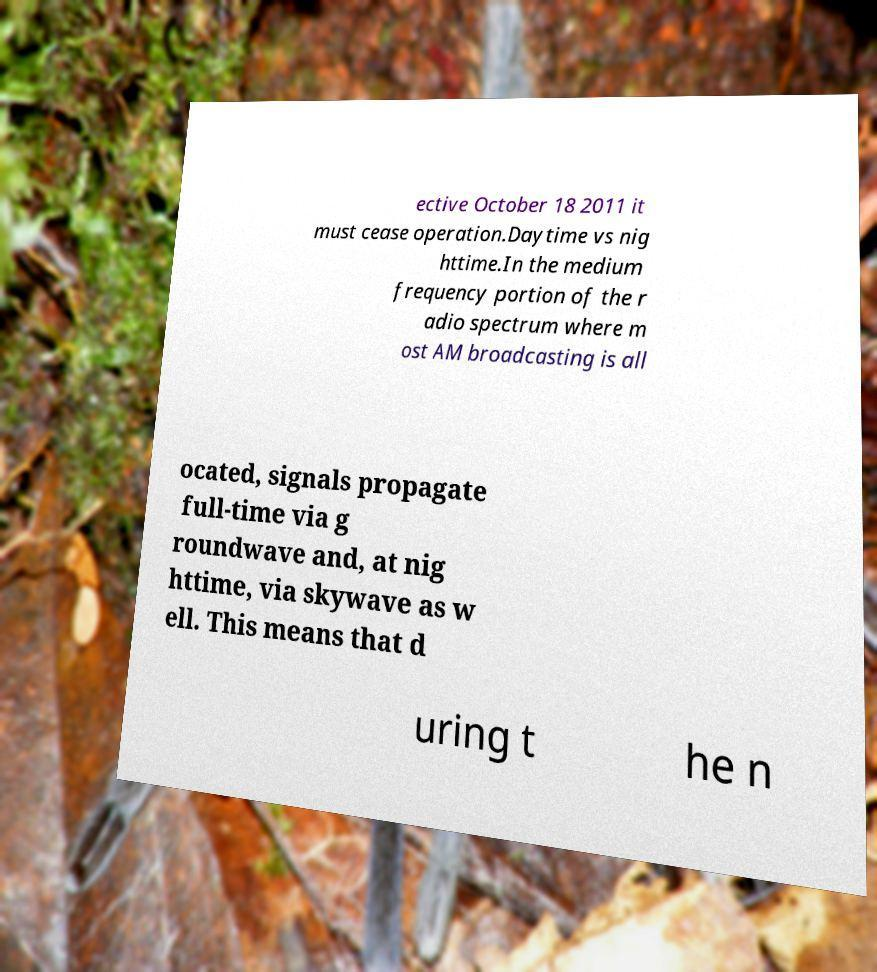What messages or text are displayed in this image? I need them in a readable, typed format. ective October 18 2011 it must cease operation.Daytime vs nig httime.In the medium frequency portion of the r adio spectrum where m ost AM broadcasting is all ocated, signals propagate full-time via g roundwave and, at nig httime, via skywave as w ell. This means that d uring t he n 